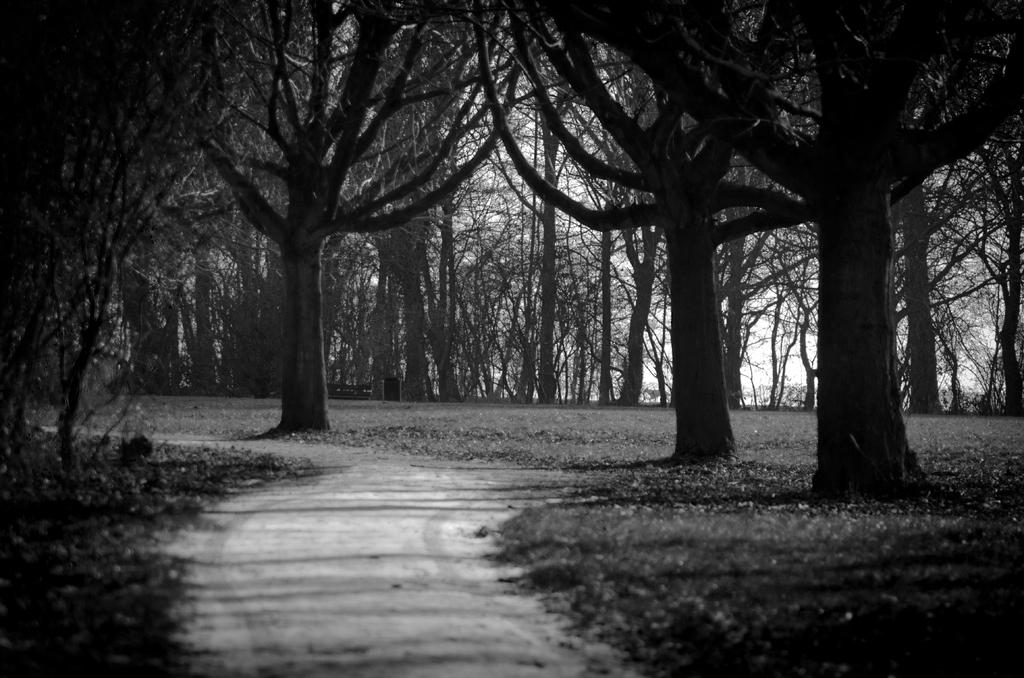What type of surface can be seen in the image? There is a path in the image. What is visible beneath the path? The ground is visible in the image. What type of vegetation is present in the image? There are trees in the image. What is visible in the background of the image? The sky is visible in the background of the image. What type of pancake can be seen on the path in the image? There is no pancake present on the path in the image. 